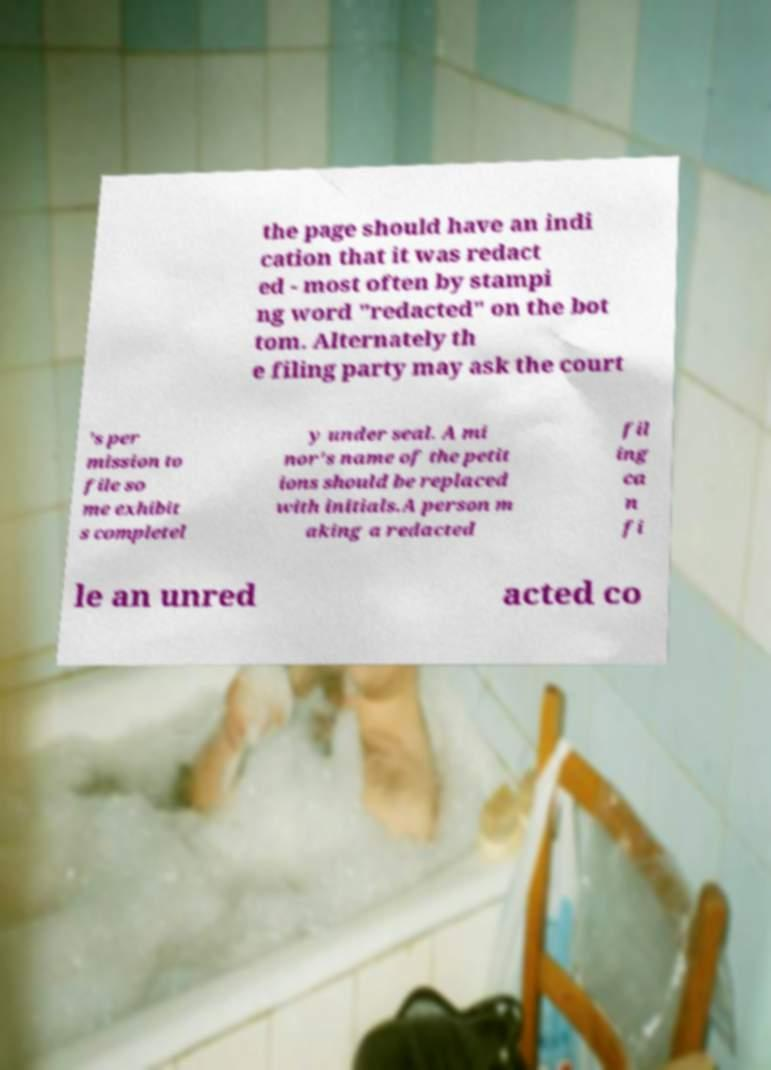There's text embedded in this image that I need extracted. Can you transcribe it verbatim? the page should have an indi cation that it was redact ed - most often by stampi ng word "redacted" on the bot tom. Alternately th e filing party may ask the court ’s per mission to file so me exhibit s completel y under seal. A mi nor's name of the petit ions should be replaced with initials.A person m aking a redacted fil ing ca n fi le an unred acted co 